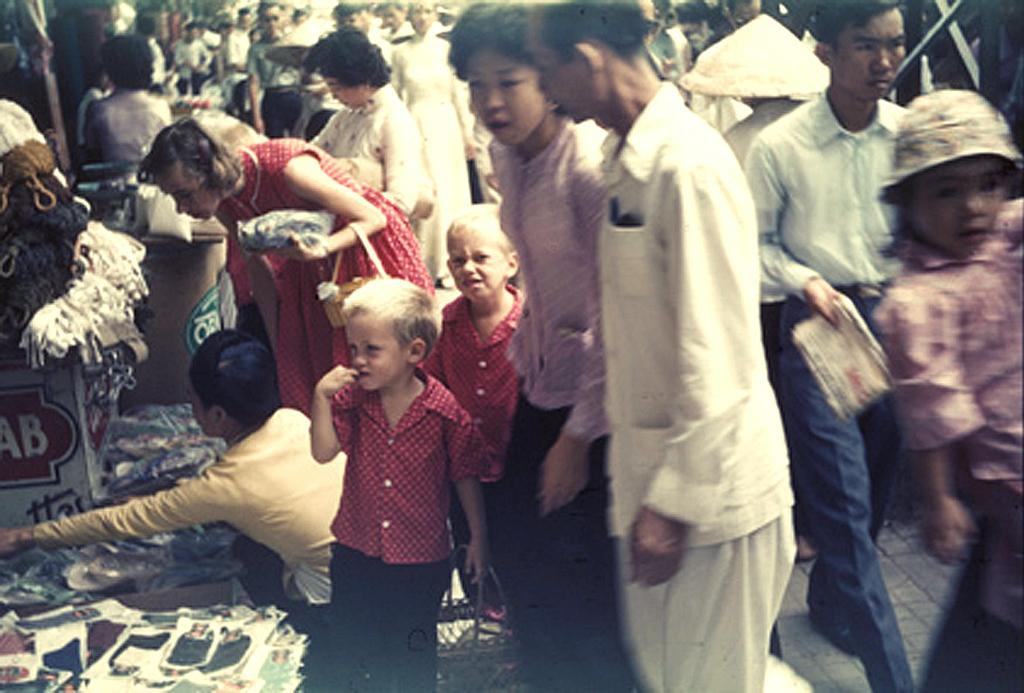Who or what can be seen in the image? There are people in the image. What is located on the left side of the image? There are stalls on the left side of the image. What type of items are visible in the image? There are clothes and posters in the image. Can you see a quiver filled with arrows in the image? No, there is no quiver filled with arrows present in the image. What color is the gold jewelry being sold at the stalls? There is no mention of gold jewelry or any jewelry for sale in the image. 